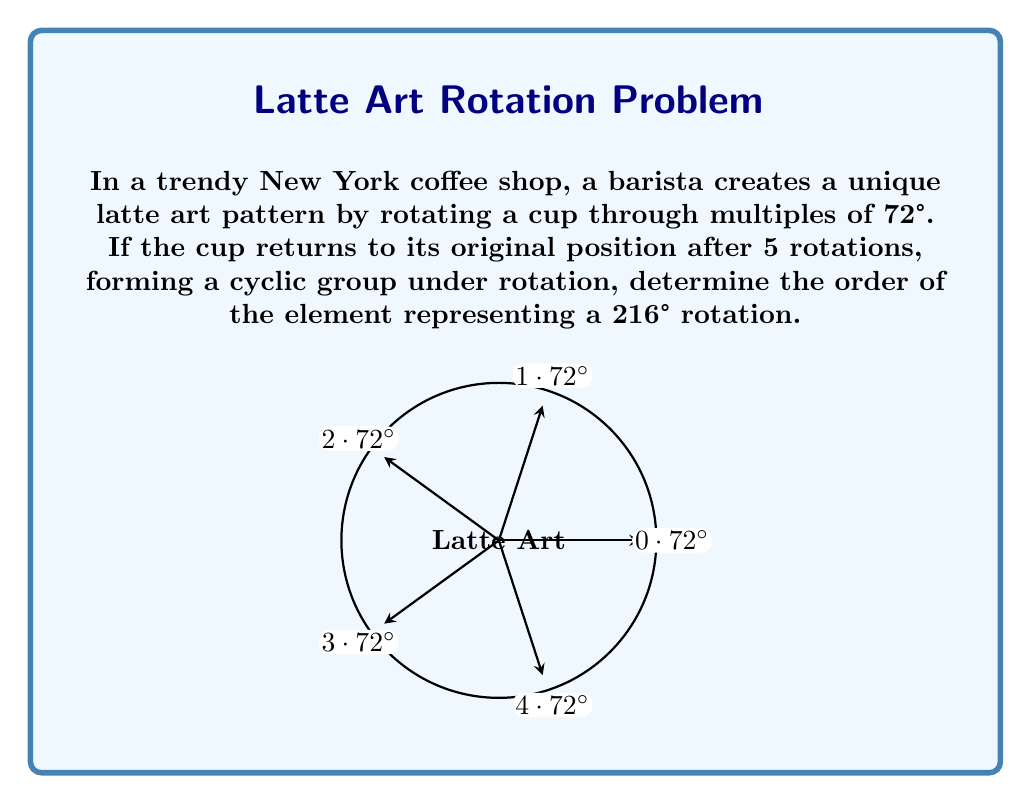Provide a solution to this math problem. Let's approach this step-by-step:

1) First, we need to understand what the order of an element means in a cyclic group. The order of an element is the smallest positive integer $n$ such that $a^n = e$, where $a$ is the element and $e$ is the identity element.

2) In this case, our group is the rotations of the cup, where a full rotation (360°) returns to the identity position. The group has order 5, as it takes 5 rotations of 72° to complete a full cycle.

3) We're asked about a 216° rotation. Let's call this element $a$. We need to find the smallest positive integer $n$ such that $a^n$ is equivalent to a full rotation (or multiple full rotations).

4) To do this, we can keep applying 216° rotations until we reach a multiple of 360°:

   $216° \equiv 216° \pmod{360°}$
   $216° \times 2 = 432° \equiv 72° \pmod{360°}$
   $216° \times 3 = 648° \equiv 288° \pmod{360°}$
   $216° \times 4 = 864° \equiv 144° \pmod{360°}$
   $216° \times 5 = 1080° \equiv 360° \pmod{360°}$

5) We see that it takes 5 applications of the 216° rotation to return to the starting position (as $1080° = 3 \times 360°$).

Therefore, the order of the element representing a 216° rotation is 5.
Answer: 5 